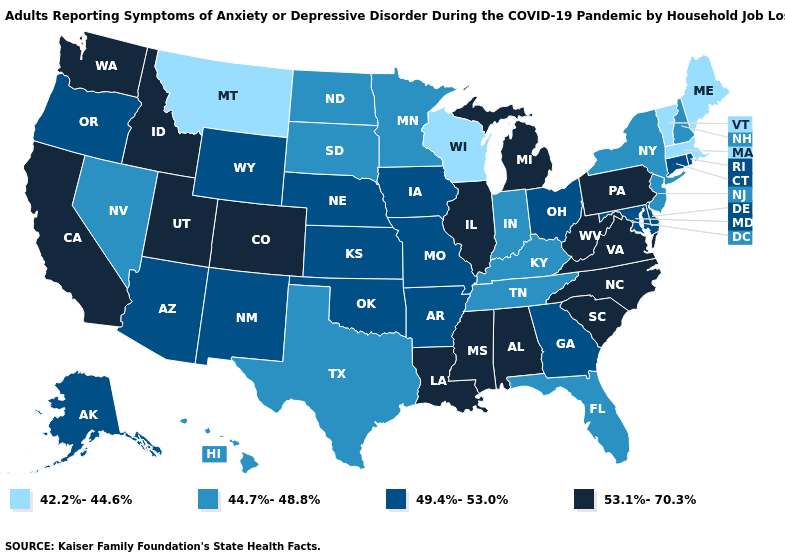Does the first symbol in the legend represent the smallest category?
Answer briefly. Yes. Does Georgia have a higher value than Tennessee?
Concise answer only. Yes. Does Tennessee have a lower value than Hawaii?
Keep it brief. No. What is the lowest value in the South?
Answer briefly. 44.7%-48.8%. Among the states that border California , which have the lowest value?
Give a very brief answer. Nevada. Does California have the highest value in the USA?
Concise answer only. Yes. Which states have the lowest value in the South?
Give a very brief answer. Florida, Kentucky, Tennessee, Texas. Name the states that have a value in the range 53.1%-70.3%?
Concise answer only. Alabama, California, Colorado, Idaho, Illinois, Louisiana, Michigan, Mississippi, North Carolina, Pennsylvania, South Carolina, Utah, Virginia, Washington, West Virginia. What is the value of Colorado?
Answer briefly. 53.1%-70.3%. Among the states that border Connecticut , which have the highest value?
Concise answer only. Rhode Island. Does South Carolina have the lowest value in the South?
Answer briefly. No. What is the lowest value in the South?
Be succinct. 44.7%-48.8%. Which states have the lowest value in the USA?
Short answer required. Maine, Massachusetts, Montana, Vermont, Wisconsin. Which states have the lowest value in the MidWest?
Quick response, please. Wisconsin. 